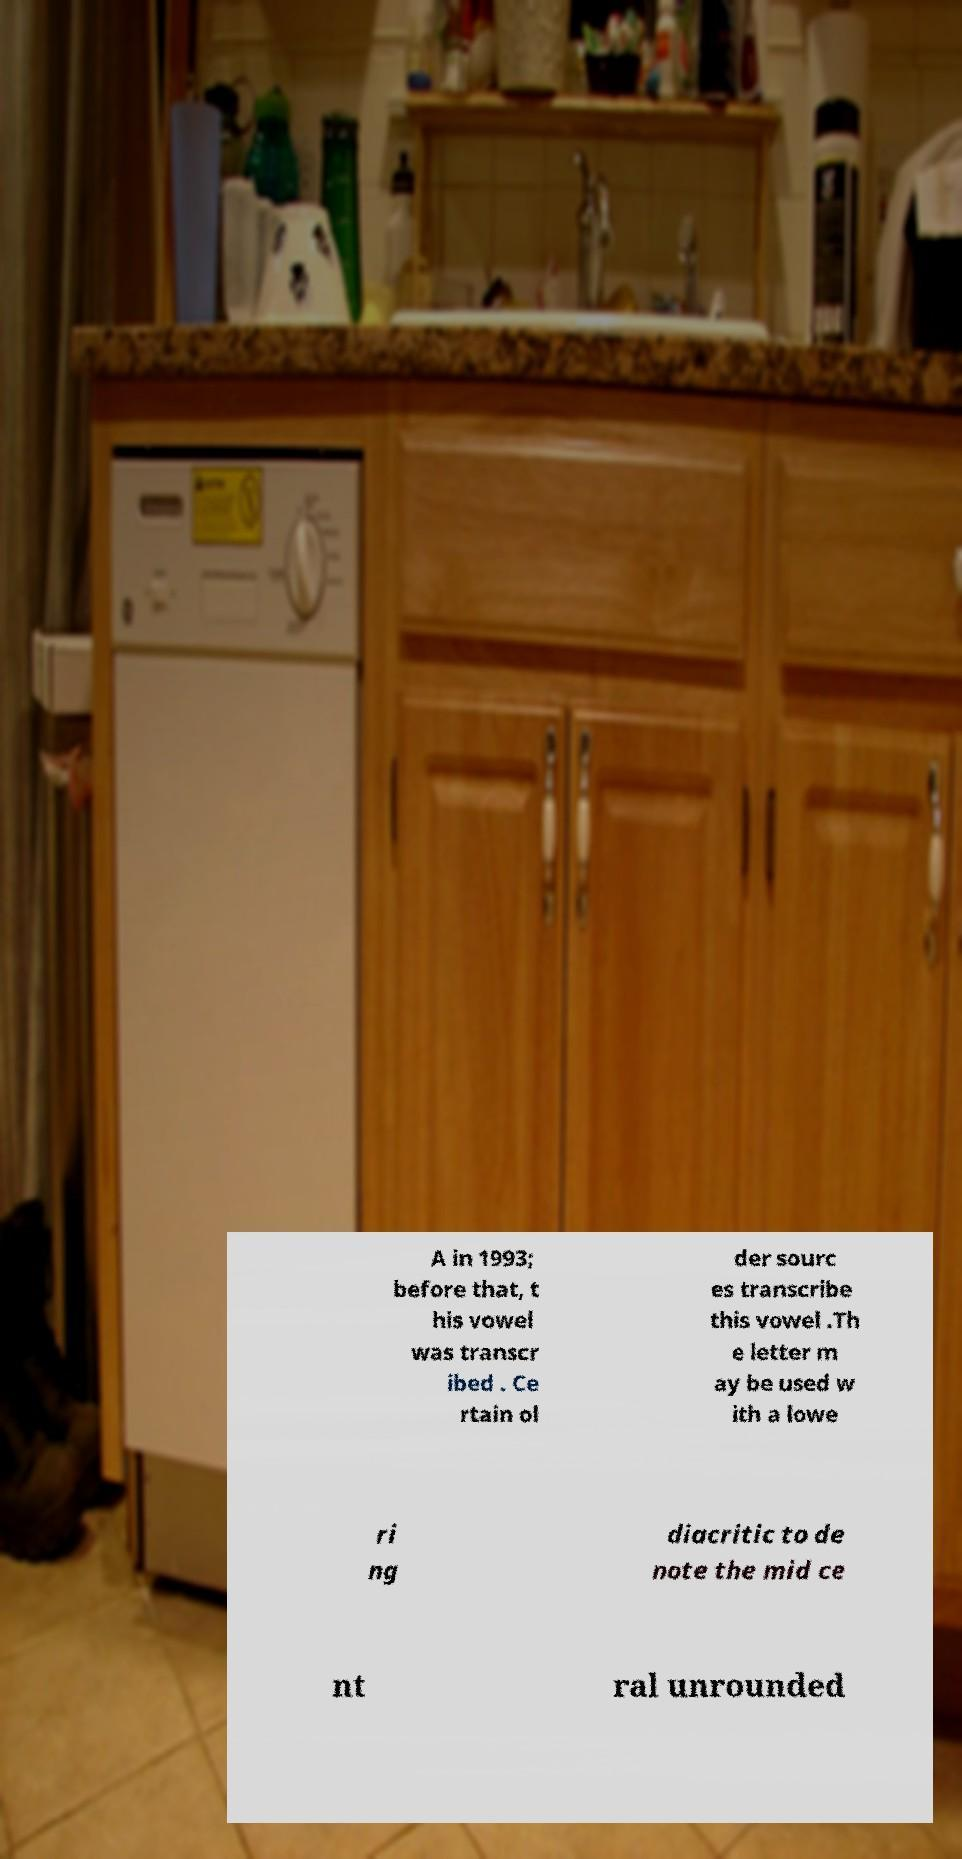Can you read and provide the text displayed in the image?This photo seems to have some interesting text. Can you extract and type it out for me? A in 1993; before that, t his vowel was transcr ibed . Ce rtain ol der sourc es transcribe this vowel .Th e letter m ay be used w ith a lowe ri ng diacritic to de note the mid ce nt ral unrounded 